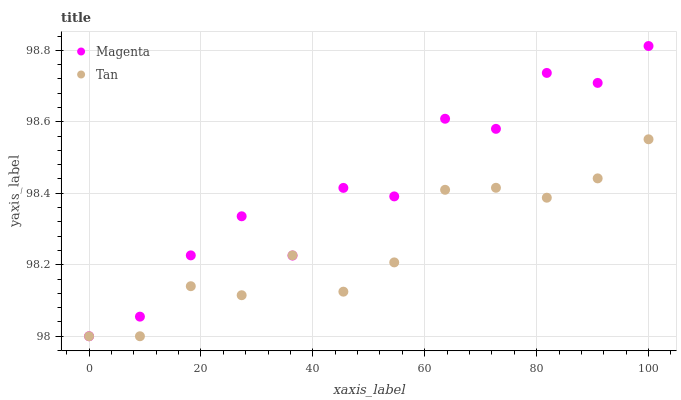Does Tan have the minimum area under the curve?
Answer yes or no. Yes. Does Magenta have the maximum area under the curve?
Answer yes or no. Yes. Does Tan have the maximum area under the curve?
Answer yes or no. No. Is Tan the smoothest?
Answer yes or no. Yes. Is Magenta the roughest?
Answer yes or no. Yes. Is Tan the roughest?
Answer yes or no. No. Does Magenta have the lowest value?
Answer yes or no. Yes. Does Magenta have the highest value?
Answer yes or no. Yes. Does Tan have the highest value?
Answer yes or no. No. Does Tan intersect Magenta?
Answer yes or no. Yes. Is Tan less than Magenta?
Answer yes or no. No. Is Tan greater than Magenta?
Answer yes or no. No. 